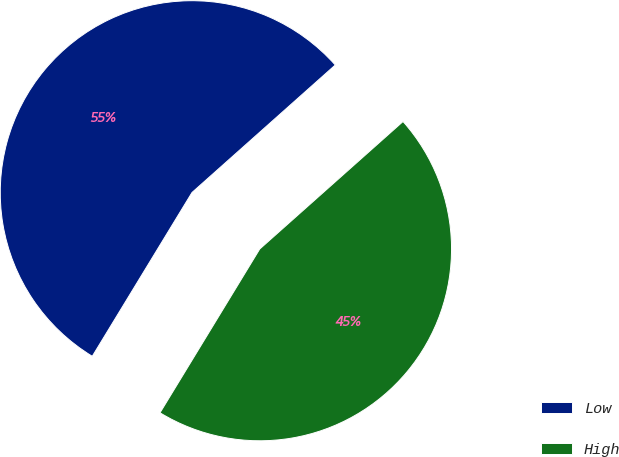Convert chart. <chart><loc_0><loc_0><loc_500><loc_500><pie_chart><fcel>Low<fcel>High<nl><fcel>54.72%<fcel>45.28%<nl></chart> 